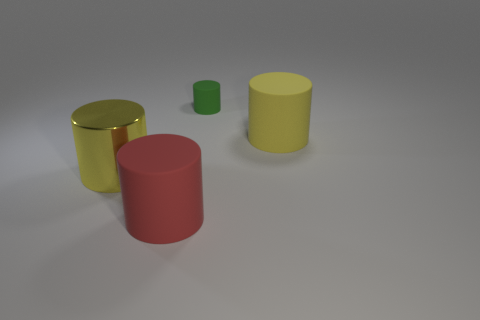Is there anything else that is the same size as the green matte thing?
Your response must be concise. No. Is there a metal cylinder that has the same size as the yellow matte cylinder?
Offer a terse response. Yes. Do the big red rubber object and the large yellow thing that is behind the big yellow metal cylinder have the same shape?
Your answer should be very brief. Yes. There is a matte thing that is behind the yellow cylinder that is right of the small rubber thing; are there any large yellow matte cylinders behind it?
Provide a short and direct response. No. The yellow matte cylinder has what size?
Ensure brevity in your answer.  Large. What number of other things are there of the same color as the metal cylinder?
Offer a very short reply. 1. Is the shape of the big yellow object to the left of the red cylinder the same as  the yellow matte object?
Offer a very short reply. Yes. There is another tiny object that is the same shape as the red object; what is its color?
Provide a succinct answer. Green. What is the size of the green rubber object that is the same shape as the red matte object?
Give a very brief answer. Small. There is a cylinder that is on the right side of the large yellow metallic thing and left of the tiny green object; what material is it?
Provide a succinct answer. Rubber. 